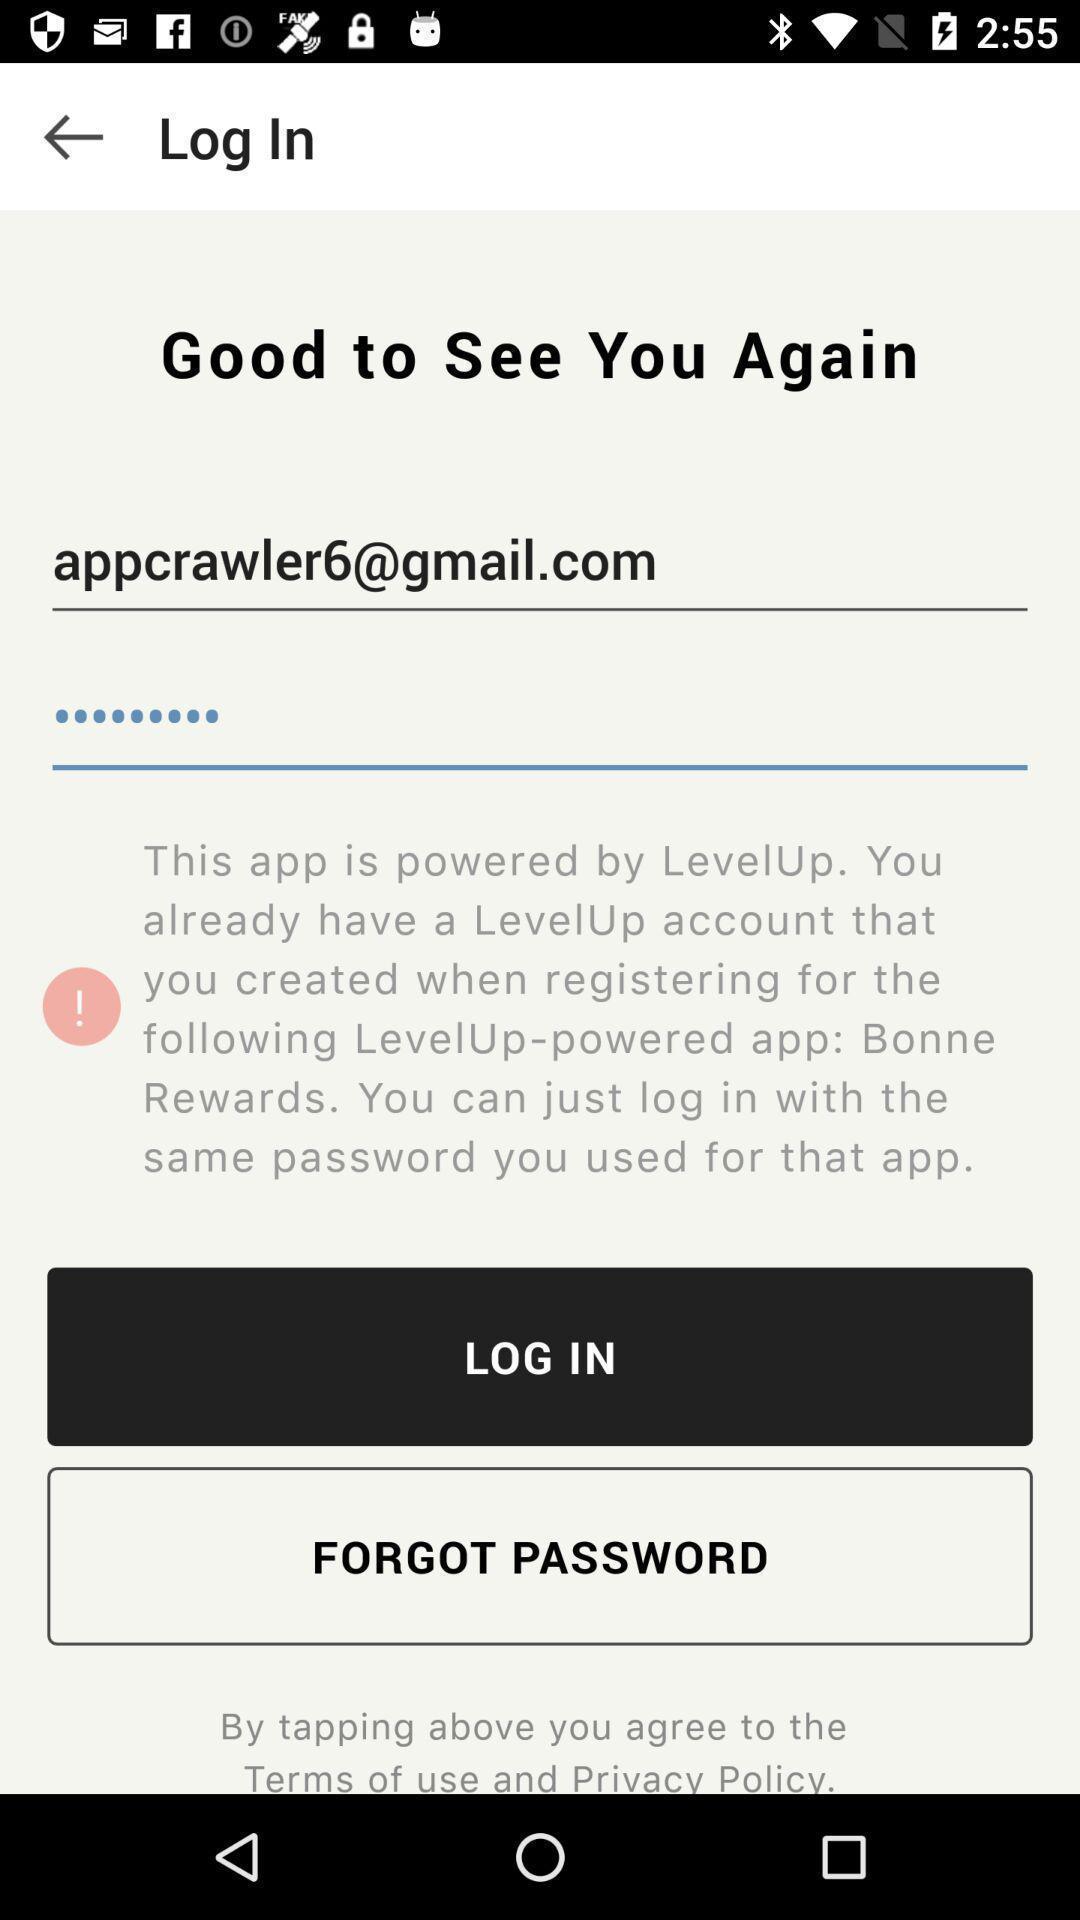What can you discern from this picture? Login to get the access from the application. 